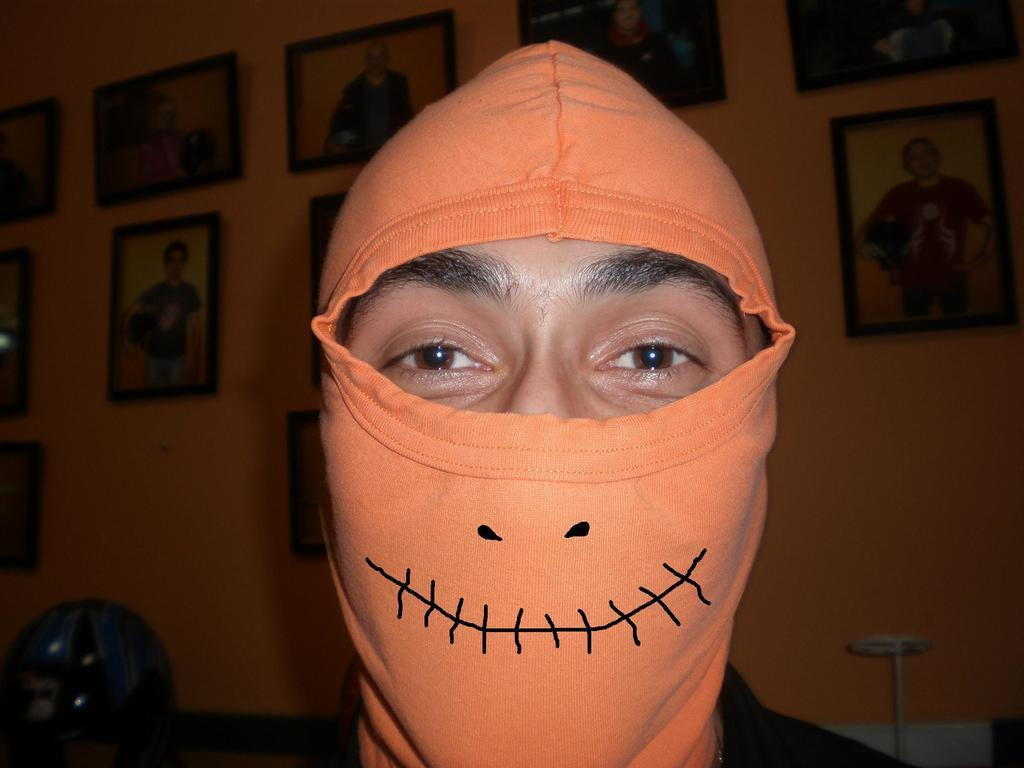Who or what is the main subject in the image? There is a person in the center of the image. What is the person wearing? The person is wearing a mask. What can be seen in the background of the image? There are frames and other objects in the background area. How many teeth can be seen in the person's mouth in the image? There is no visible teeth in the person's mouth in the image, as they are wearing a mask. What type of crowd is present in the image? There is no crowd present in the image; it features a single person wearing a mask. 